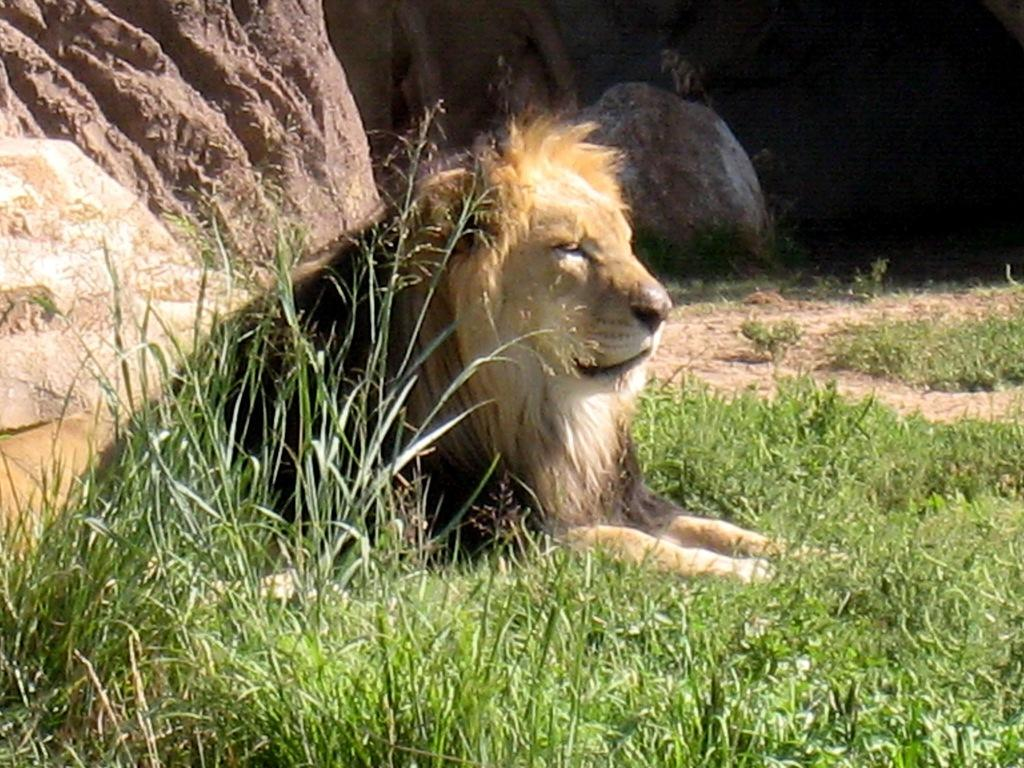What animal is the main subject of the image? There is a lion in the image. What is the lion standing on? The lion is on the grass floor. What type of terrain can be seen in the background of the image? There are rocks visible in the background of the image. What type of pet does the lion's uncle have in the image? There is no pet or uncle present in the image; it features a lion standing on a grass floor with rocks visible in the background. 